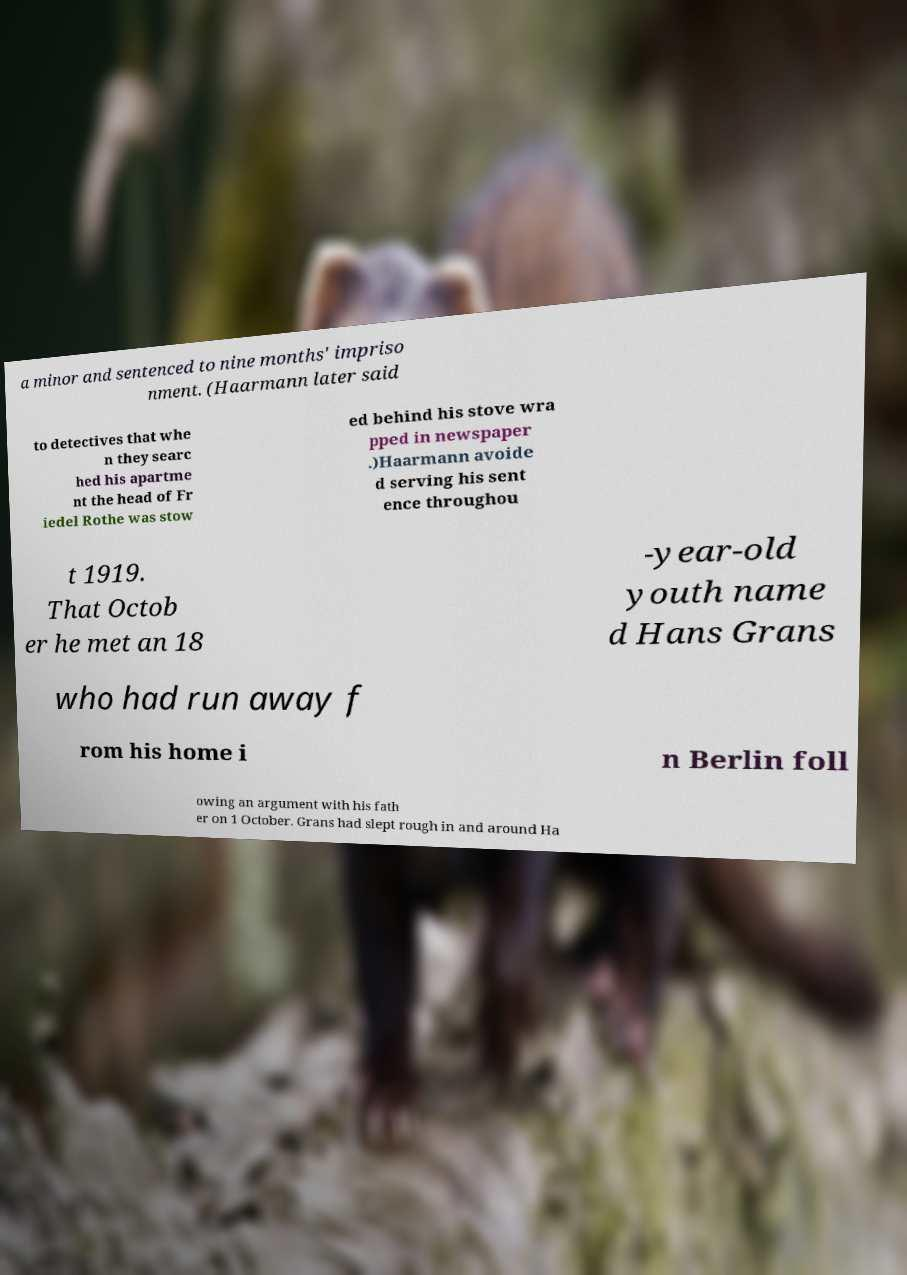Can you accurately transcribe the text from the provided image for me? a minor and sentenced to nine months' impriso nment. (Haarmann later said to detectives that whe n they searc hed his apartme nt the head of Fr iedel Rothe was stow ed behind his stove wra pped in newspaper .)Haarmann avoide d serving his sent ence throughou t 1919. That Octob er he met an 18 -year-old youth name d Hans Grans who had run away f rom his home i n Berlin foll owing an argument with his fath er on 1 October. Grans had slept rough in and around Ha 